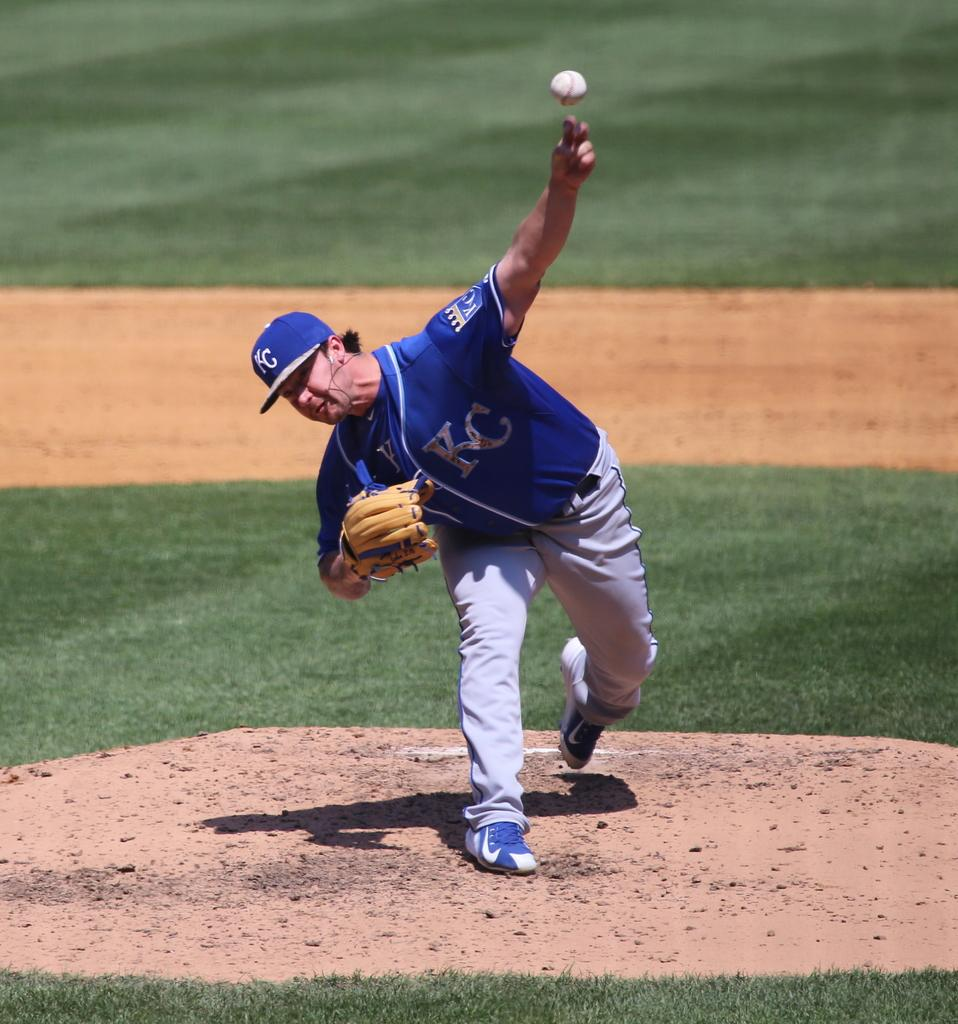<image>
Give a short and clear explanation of the subsequent image. a player from KC getting ready to throw the ball 